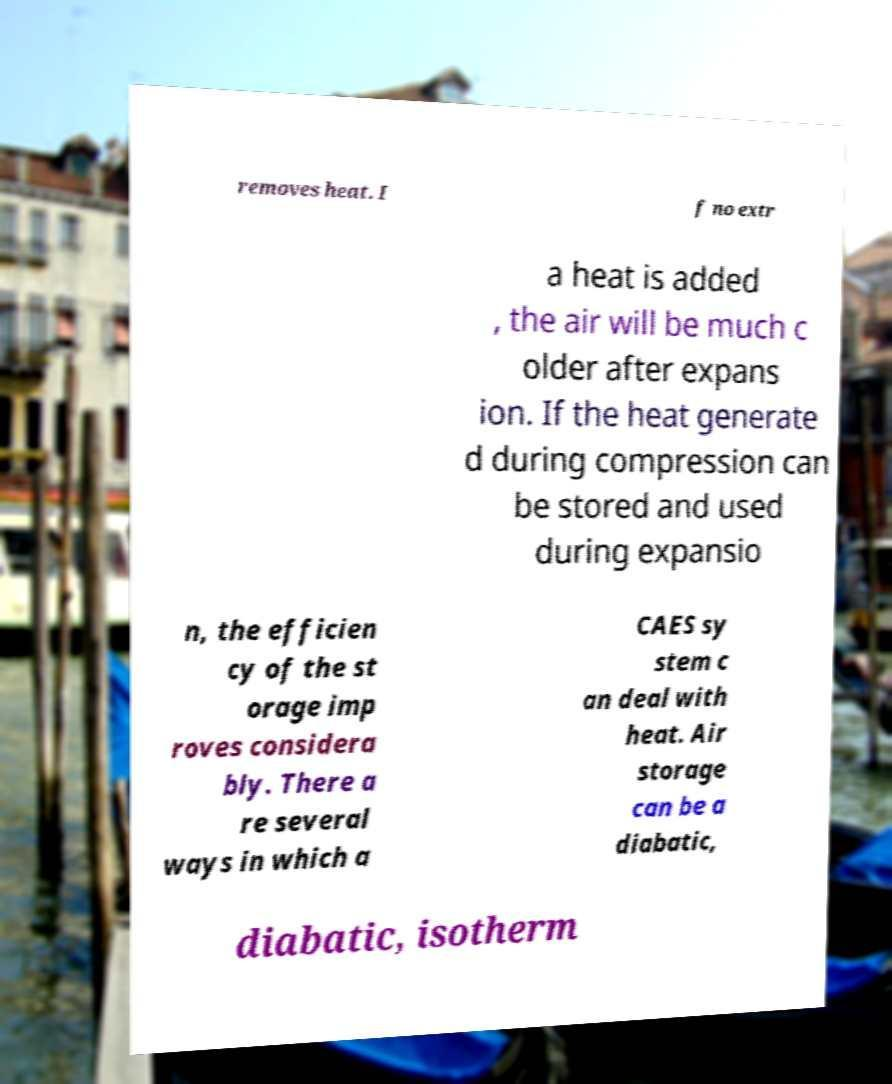Please identify and transcribe the text found in this image. removes heat. I f no extr a heat is added , the air will be much c older after expans ion. If the heat generate d during compression can be stored and used during expansio n, the efficien cy of the st orage imp roves considera bly. There a re several ways in which a CAES sy stem c an deal with heat. Air storage can be a diabatic, diabatic, isotherm 